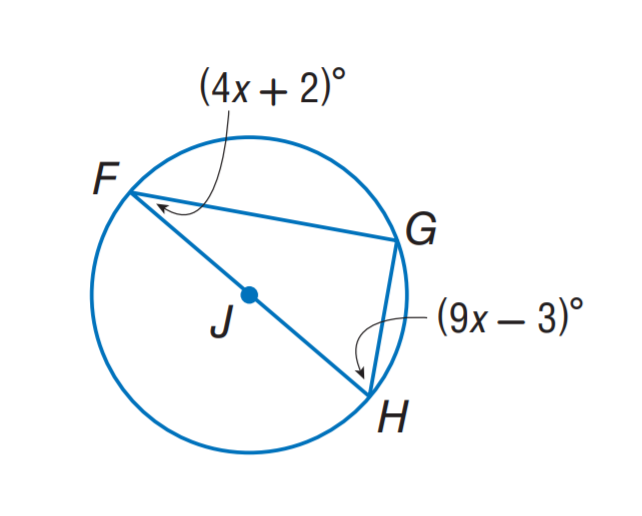Question: Find m \angle F.
Choices:
A. 20
B. 30
C. 40
D. 60
Answer with the letter. Answer: B 